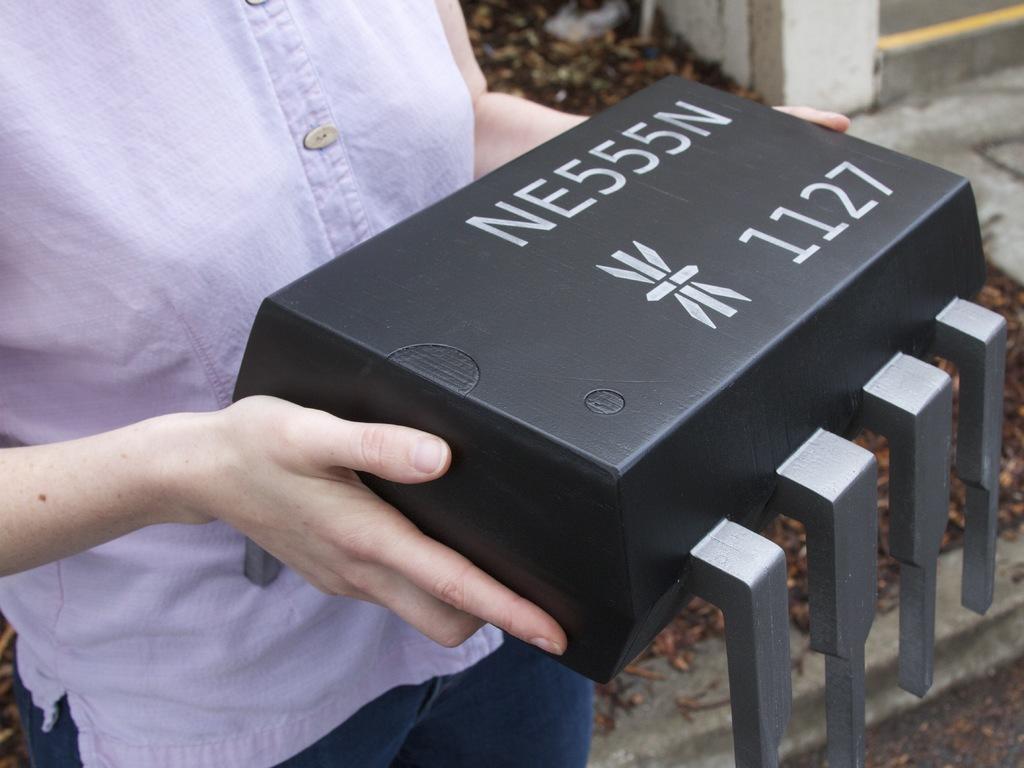Can you describe this image briefly? In this image there is a person standing and holding a box , which is in the model of a microcontroller, and in the background there are leaves. 